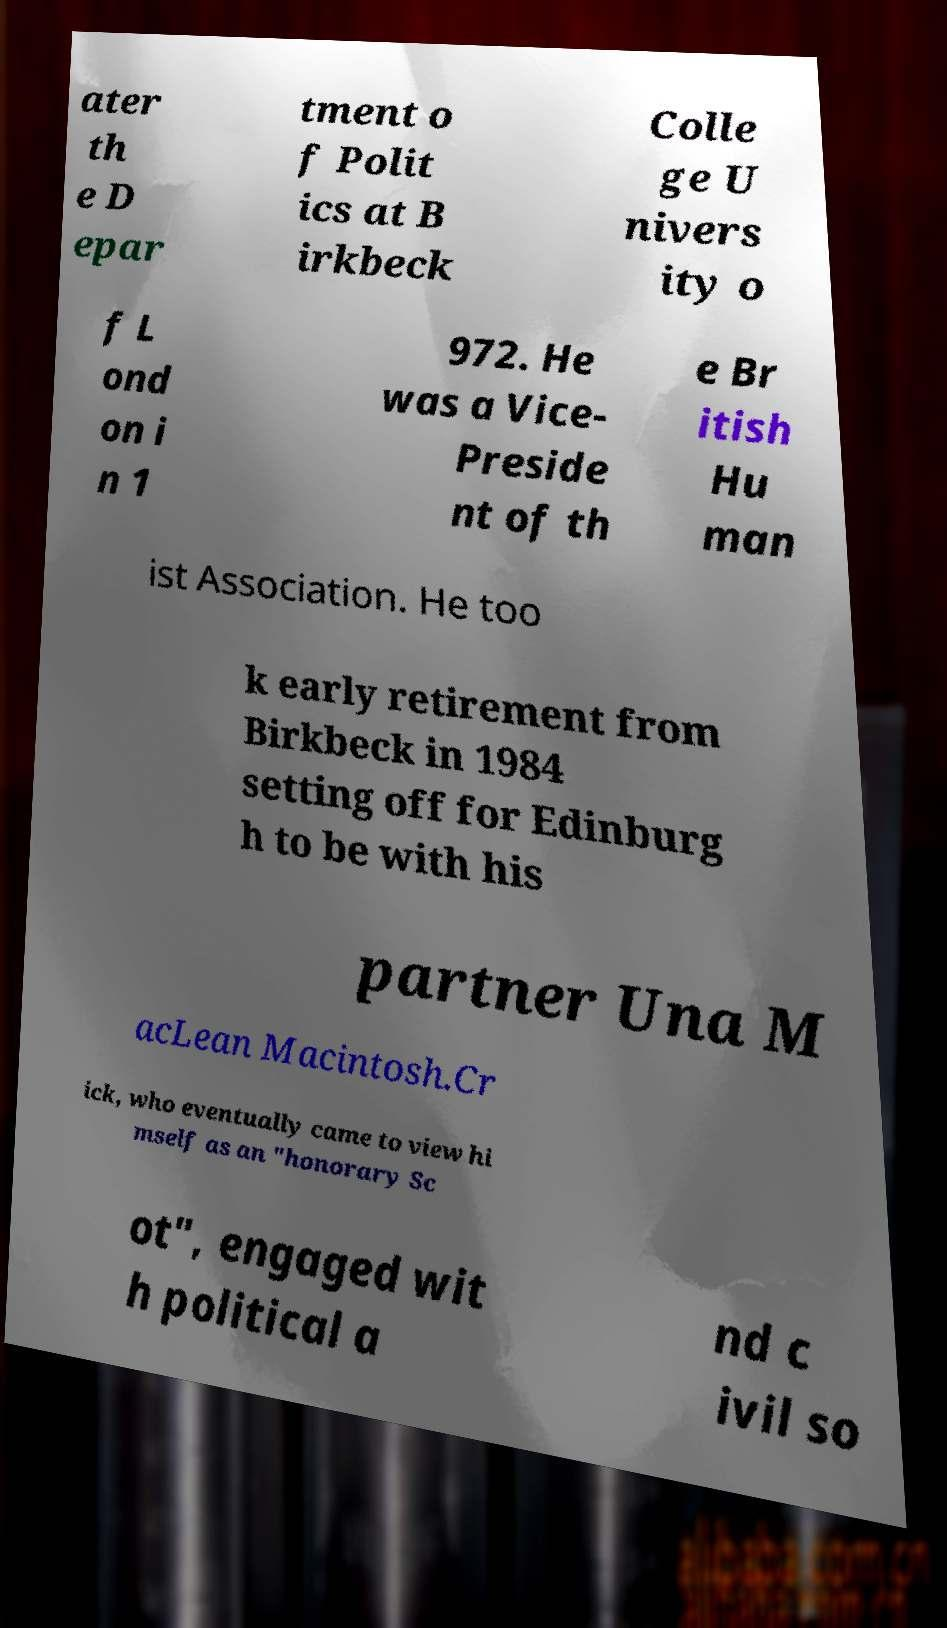For documentation purposes, I need the text within this image transcribed. Could you provide that? ater th e D epar tment o f Polit ics at B irkbeck Colle ge U nivers ity o f L ond on i n 1 972. He was a Vice- Preside nt of th e Br itish Hu man ist Association. He too k early retirement from Birkbeck in 1984 setting off for Edinburg h to be with his partner Una M acLean Macintosh.Cr ick, who eventually came to view hi mself as an "honorary Sc ot", engaged wit h political a nd c ivil so 